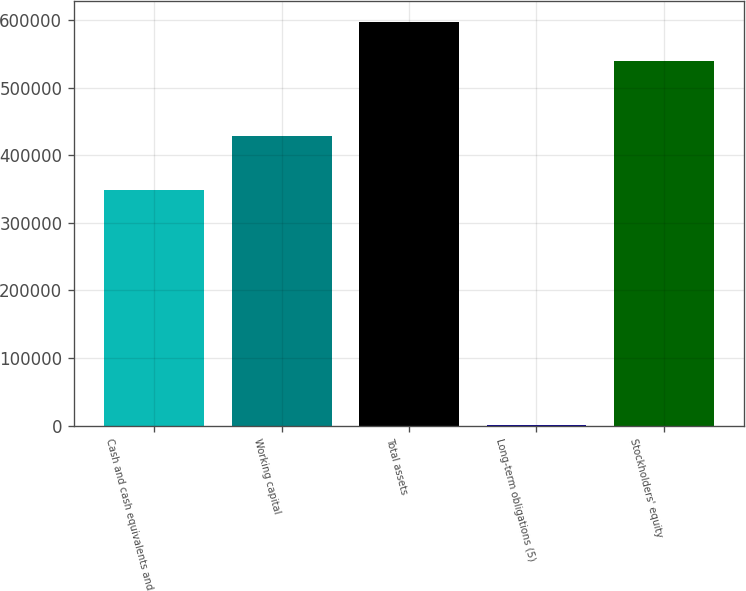Convert chart. <chart><loc_0><loc_0><loc_500><loc_500><bar_chart><fcel>Cash and cash equivalents and<fcel>Working capital<fcel>Total assets<fcel>Long-term obligations (5)<fcel>Stockholders' equity<nl><fcel>348577<fcel>427676<fcel>597477<fcel>1613<fcel>539768<nl></chart> 